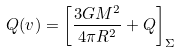Convert formula to latex. <formula><loc_0><loc_0><loc_500><loc_500>Q ( v ) = \left [ \frac { 3 G M ^ { 2 } } { 4 \pi R ^ { 2 } } + Q \right ] _ { \Sigma }</formula> 